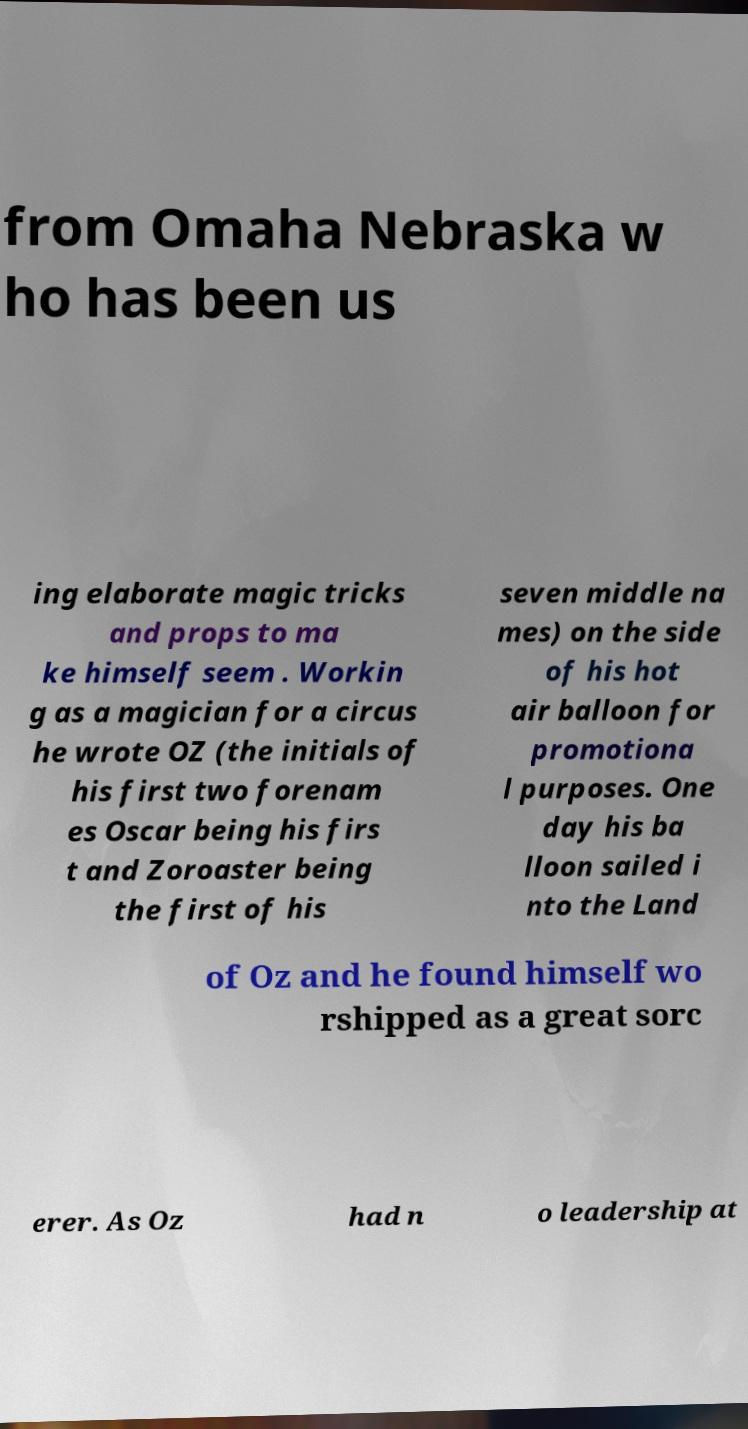Can you accurately transcribe the text from the provided image for me? from Omaha Nebraska w ho has been us ing elaborate magic tricks and props to ma ke himself seem . Workin g as a magician for a circus he wrote OZ (the initials of his first two forenam es Oscar being his firs t and Zoroaster being the first of his seven middle na mes) on the side of his hot air balloon for promotiona l purposes. One day his ba lloon sailed i nto the Land of Oz and he found himself wo rshipped as a great sorc erer. As Oz had n o leadership at 